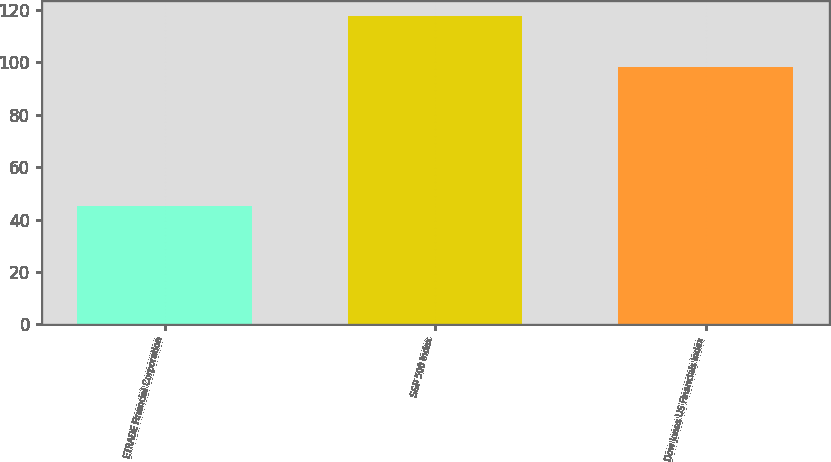<chart> <loc_0><loc_0><loc_500><loc_500><bar_chart><fcel>ETRADE Financial Corporation<fcel>S&P 500 Index<fcel>Dow Jones US Financials Index<nl><fcel>45.23<fcel>117.49<fcel>98.24<nl></chart> 